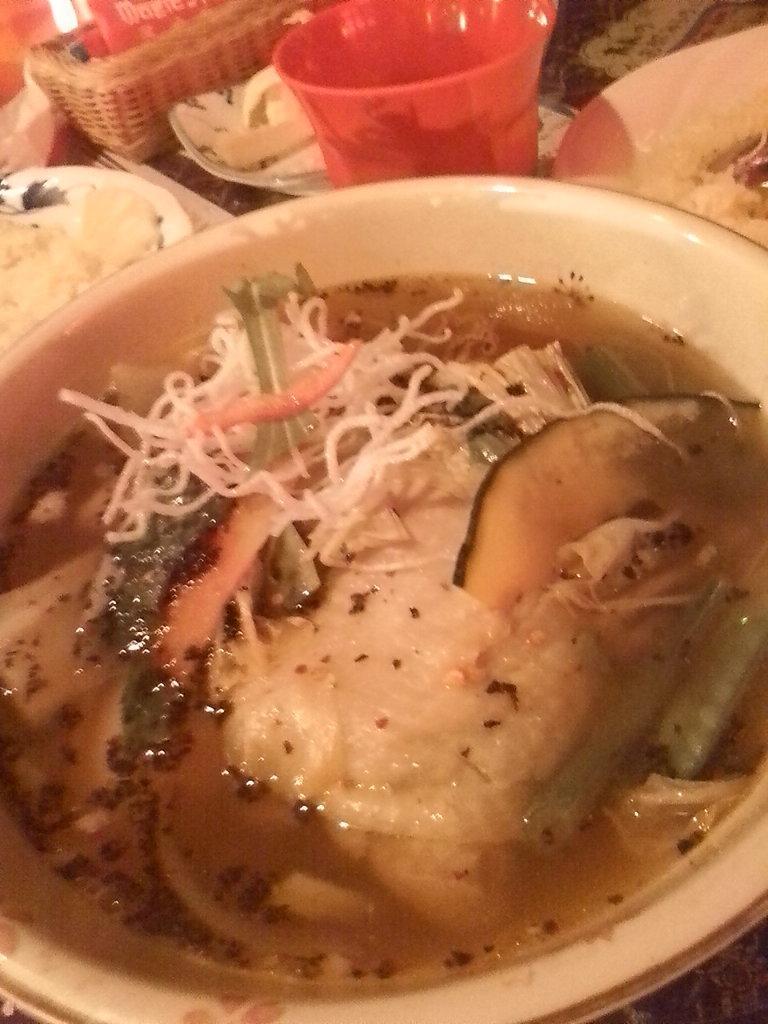How would you summarize this image in a sentence or two? In the picture we can see a bowl with some curry and soup in it and besides it, we can see a red color glass and some plates with food in it. 